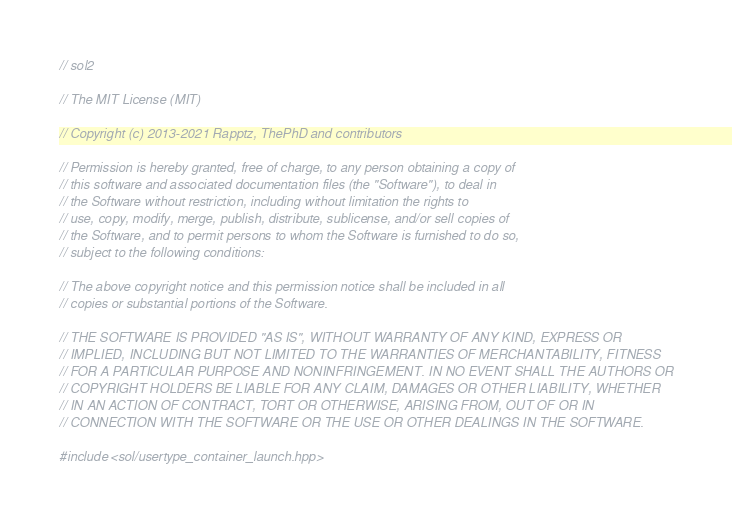Convert code to text. <code><loc_0><loc_0><loc_500><loc_500><_C++_>// sol2

// The MIT License (MIT)

// Copyright (c) 2013-2021 Rapptz, ThePhD and contributors

// Permission is hereby granted, free of charge, to any person obtaining a copy of
// this software and associated documentation files (the "Software"), to deal in
// the Software without restriction, including without limitation the rights to
// use, copy, modify, merge, publish, distribute, sublicense, and/or sell copies of
// the Software, and to permit persons to whom the Software is furnished to do so,
// subject to the following conditions:

// The above copyright notice and this permission notice shall be included in all
// copies or substantial portions of the Software.

// THE SOFTWARE IS PROVIDED "AS IS", WITHOUT WARRANTY OF ANY KIND, EXPRESS OR
// IMPLIED, INCLUDING BUT NOT LIMITED TO THE WARRANTIES OF MERCHANTABILITY, FITNESS
// FOR A PARTICULAR PURPOSE AND NONINFRINGEMENT. IN NO EVENT SHALL THE AUTHORS OR
// COPYRIGHT HOLDERS BE LIABLE FOR ANY CLAIM, DAMAGES OR OTHER LIABILITY, WHETHER
// IN AN ACTION OF CONTRACT, TORT OR OTHERWISE, ARISING FROM, OUT OF OR IN
// CONNECTION WITH THE SOFTWARE OR THE USE OR OTHER DEALINGS IN THE SOFTWARE.

#include <sol/usertype_container_launch.hpp>
</code> 